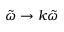Convert formula to latex. <formula><loc_0><loc_0><loc_500><loc_500>\tilde { \omega } \rightarrow k \tilde { \omega }</formula> 